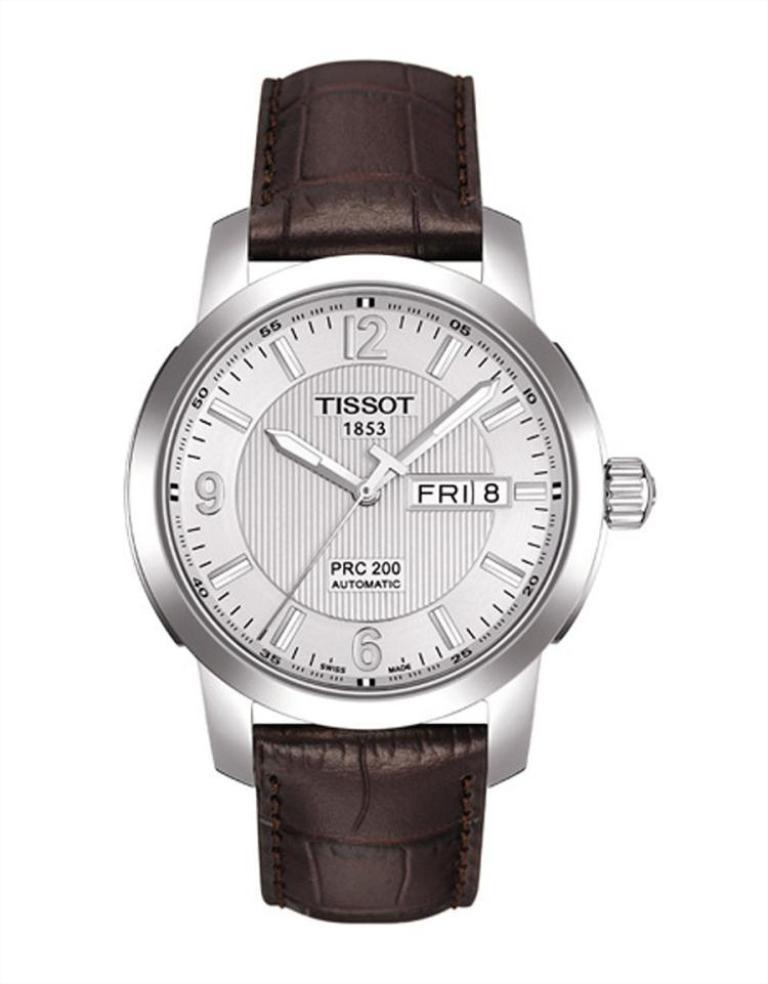What time does this watch say?
Make the answer very short. 10:08. What day of the week does the watch show?
Offer a very short reply. Friday. 